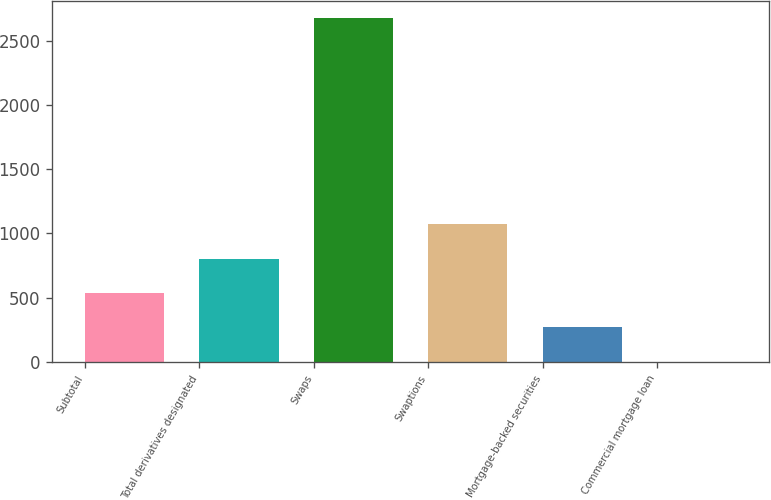Convert chart to OTSL. <chart><loc_0><loc_0><loc_500><loc_500><bar_chart><fcel>Subtotal<fcel>Total derivatives designated<fcel>Swaps<fcel>Swaptions<fcel>Mortgage-backed securities<fcel>Commercial mortgage loan<nl><fcel>537<fcel>804<fcel>2673<fcel>1071<fcel>270<fcel>3<nl></chart> 